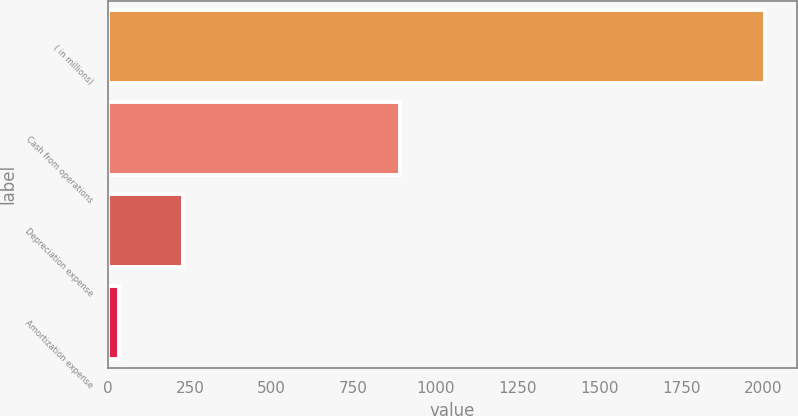<chart> <loc_0><loc_0><loc_500><loc_500><bar_chart><fcel>( in millions)<fcel>Cash from operations<fcel>Depreciation expense<fcel>Amortization expense<nl><fcel>2004<fcel>891<fcel>230.1<fcel>33<nl></chart> 